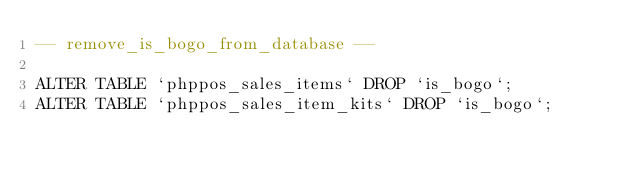<code> <loc_0><loc_0><loc_500><loc_500><_SQL_>-- remove_is_bogo_from_database --

ALTER TABLE `phppos_sales_items` DROP `is_bogo`;
ALTER TABLE `phppos_sales_item_kits` DROP `is_bogo`;</code> 